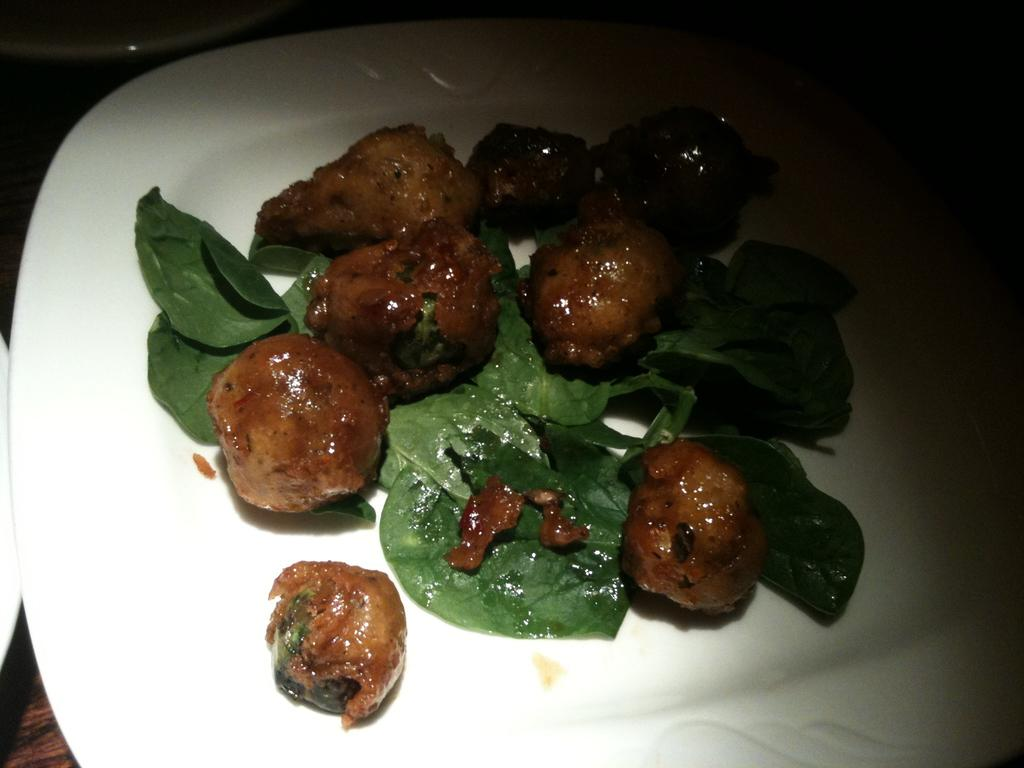What is on the plate that is visible in the image? There are food items on a plate in the image. Where is the plate located in the image? The plate is on a table in the image. What else can be seen beside the plate in the image? There are other objects beside the plate in the image. What type of fuel is being used by the food items in the image? There is no fuel involved in the image, as it features food items on a plate. How many visitors are present in the image? There is no indication of any visitors in the image; it only shows a plate with food items on a table. 